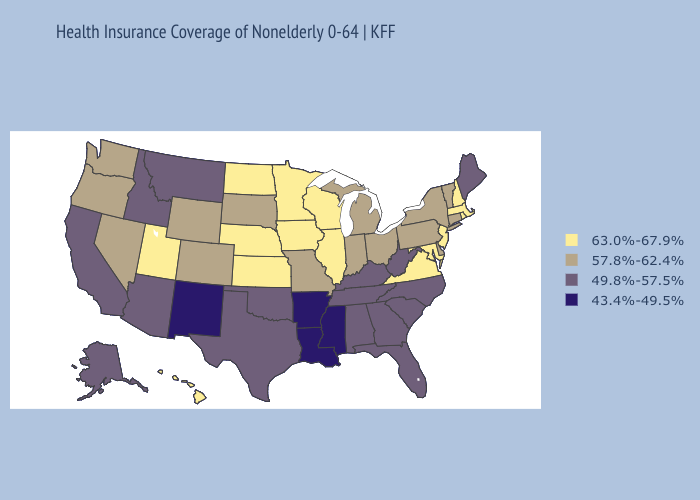Name the states that have a value in the range 57.8%-62.4%?
Be succinct. Colorado, Connecticut, Delaware, Indiana, Michigan, Missouri, Nevada, New York, Ohio, Oregon, Pennsylvania, South Dakota, Vermont, Washington, Wyoming. Does North Dakota have a lower value than Michigan?
Be succinct. No. Does Massachusetts have the highest value in the Northeast?
Quick response, please. Yes. What is the highest value in the USA?
Answer briefly. 63.0%-67.9%. What is the lowest value in states that border North Carolina?
Concise answer only. 49.8%-57.5%. Name the states that have a value in the range 57.8%-62.4%?
Be succinct. Colorado, Connecticut, Delaware, Indiana, Michigan, Missouri, Nevada, New York, Ohio, Oregon, Pennsylvania, South Dakota, Vermont, Washington, Wyoming. Among the states that border Nebraska , does Iowa have the highest value?
Answer briefly. Yes. Name the states that have a value in the range 57.8%-62.4%?
Quick response, please. Colorado, Connecticut, Delaware, Indiana, Michigan, Missouri, Nevada, New York, Ohio, Oregon, Pennsylvania, South Dakota, Vermont, Washington, Wyoming. Does Virginia have the highest value in the USA?
Be succinct. Yes. What is the value of Maryland?
Keep it brief. 63.0%-67.9%. Which states have the highest value in the USA?
Give a very brief answer. Hawaii, Illinois, Iowa, Kansas, Maryland, Massachusetts, Minnesota, Nebraska, New Hampshire, New Jersey, North Dakota, Rhode Island, Utah, Virginia, Wisconsin. Does Washington have a higher value than New Hampshire?
Quick response, please. No. Which states have the highest value in the USA?
Keep it brief. Hawaii, Illinois, Iowa, Kansas, Maryland, Massachusetts, Minnesota, Nebraska, New Hampshire, New Jersey, North Dakota, Rhode Island, Utah, Virginia, Wisconsin. What is the value of Alaska?
Concise answer only. 49.8%-57.5%. Name the states that have a value in the range 49.8%-57.5%?
Answer briefly. Alabama, Alaska, Arizona, California, Florida, Georgia, Idaho, Kentucky, Maine, Montana, North Carolina, Oklahoma, South Carolina, Tennessee, Texas, West Virginia. 